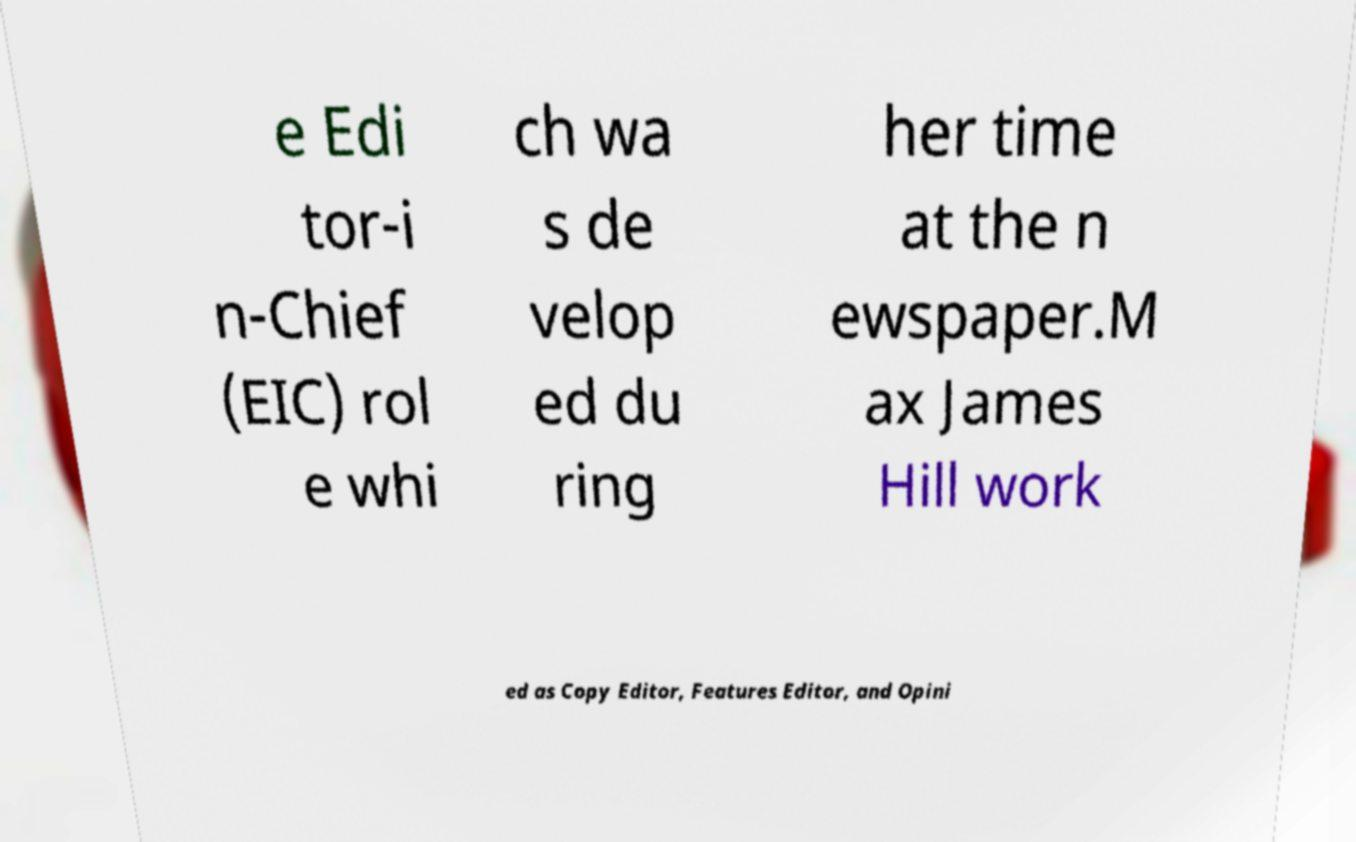Could you extract and type out the text from this image? e Edi tor-i n-Chief (EIC) rol e whi ch wa s de velop ed du ring her time at the n ewspaper.M ax James Hill work ed as Copy Editor, Features Editor, and Opini 